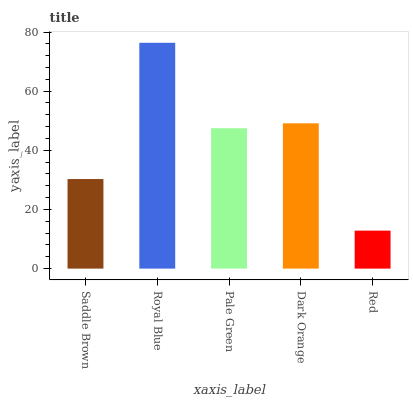Is Red the minimum?
Answer yes or no. Yes. Is Royal Blue the maximum?
Answer yes or no. Yes. Is Pale Green the minimum?
Answer yes or no. No. Is Pale Green the maximum?
Answer yes or no. No. Is Royal Blue greater than Pale Green?
Answer yes or no. Yes. Is Pale Green less than Royal Blue?
Answer yes or no. Yes. Is Pale Green greater than Royal Blue?
Answer yes or no. No. Is Royal Blue less than Pale Green?
Answer yes or no. No. Is Pale Green the high median?
Answer yes or no. Yes. Is Pale Green the low median?
Answer yes or no. Yes. Is Royal Blue the high median?
Answer yes or no. No. Is Dark Orange the low median?
Answer yes or no. No. 